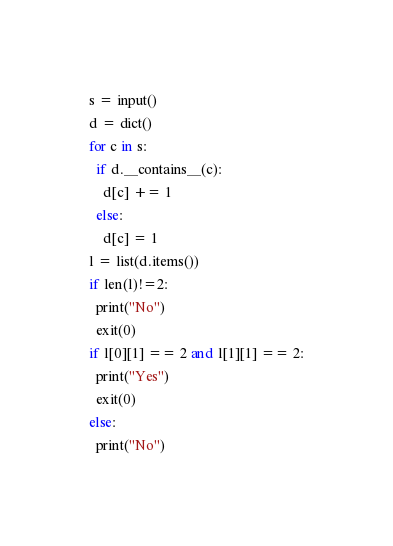Convert code to text. <code><loc_0><loc_0><loc_500><loc_500><_Python_>s = input()
d = dict()
for c in s:
  if d.__contains__(c):
    d[c] += 1
  else:
    d[c] = 1
l = list(d.items())
if len(l)!=2:
  print("No")
  exit(0)
if l[0][1] == 2 and l[1][1] == 2:
  print("Yes")
  exit(0)
else:
  print("No")</code> 